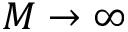Convert formula to latex. <formula><loc_0><loc_0><loc_500><loc_500>M \rightarrow \infty</formula> 